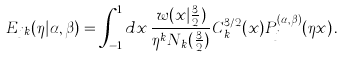<formula> <loc_0><loc_0><loc_500><loc_500>E _ { j k } ( \eta | \alpha , \beta ) = \int _ { - 1 } ^ { 1 } d x \, \frac { w ( x | \frac { 3 } { 2 } ) } { \eta ^ { k } N _ { k } ( \frac { 3 } { 2 } ) } C _ { k } ^ { 3 / 2 } ( x ) P _ { j } ^ { ( \alpha , \beta ) } ( \eta x ) \, .</formula> 